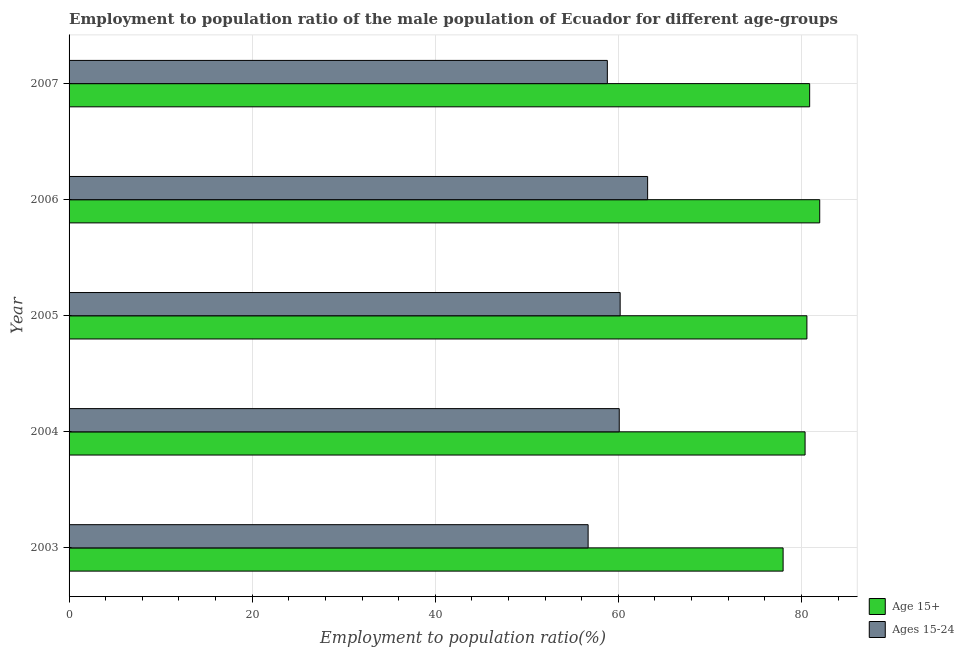How many different coloured bars are there?
Keep it short and to the point. 2. How many groups of bars are there?
Your answer should be compact. 5. Are the number of bars on each tick of the Y-axis equal?
Provide a succinct answer. Yes. How many bars are there on the 2nd tick from the top?
Make the answer very short. 2. How many bars are there on the 5th tick from the bottom?
Offer a very short reply. 2. What is the employment to population ratio(age 15+) in 2007?
Make the answer very short. 80.9. Across all years, what is the maximum employment to population ratio(age 15-24)?
Your response must be concise. 63.2. Across all years, what is the minimum employment to population ratio(age 15-24)?
Provide a succinct answer. 56.7. What is the total employment to population ratio(age 15-24) in the graph?
Keep it short and to the point. 299. What is the difference between the employment to population ratio(age 15+) in 2003 and that in 2006?
Offer a terse response. -4. What is the difference between the employment to population ratio(age 15+) in 2006 and the employment to population ratio(age 15-24) in 2005?
Give a very brief answer. 21.8. What is the average employment to population ratio(age 15-24) per year?
Your answer should be compact. 59.8. In the year 2003, what is the difference between the employment to population ratio(age 15+) and employment to population ratio(age 15-24)?
Your response must be concise. 21.3. Is the difference between the employment to population ratio(age 15+) in 2004 and 2005 greater than the difference between the employment to population ratio(age 15-24) in 2004 and 2005?
Offer a terse response. No. What is the difference between the highest and the second highest employment to population ratio(age 15-24)?
Ensure brevity in your answer.  3. In how many years, is the employment to population ratio(age 15+) greater than the average employment to population ratio(age 15+) taken over all years?
Keep it short and to the point. 4. What does the 1st bar from the top in 2004 represents?
Make the answer very short. Ages 15-24. What does the 2nd bar from the bottom in 2003 represents?
Offer a very short reply. Ages 15-24. How many bars are there?
Your answer should be very brief. 10. Are all the bars in the graph horizontal?
Your answer should be very brief. Yes. How many years are there in the graph?
Provide a short and direct response. 5. Does the graph contain any zero values?
Your response must be concise. No. Where does the legend appear in the graph?
Your answer should be very brief. Bottom right. How many legend labels are there?
Offer a terse response. 2. What is the title of the graph?
Your answer should be very brief. Employment to population ratio of the male population of Ecuador for different age-groups. Does "Netherlands" appear as one of the legend labels in the graph?
Your answer should be very brief. No. What is the label or title of the X-axis?
Keep it short and to the point. Employment to population ratio(%). What is the label or title of the Y-axis?
Provide a succinct answer. Year. What is the Employment to population ratio(%) of Age 15+ in 2003?
Offer a very short reply. 78. What is the Employment to population ratio(%) of Ages 15-24 in 2003?
Provide a short and direct response. 56.7. What is the Employment to population ratio(%) in Age 15+ in 2004?
Provide a succinct answer. 80.4. What is the Employment to population ratio(%) in Ages 15-24 in 2004?
Provide a short and direct response. 60.1. What is the Employment to population ratio(%) in Age 15+ in 2005?
Provide a short and direct response. 80.6. What is the Employment to population ratio(%) of Ages 15-24 in 2005?
Keep it short and to the point. 60.2. What is the Employment to population ratio(%) in Ages 15-24 in 2006?
Offer a very short reply. 63.2. What is the Employment to population ratio(%) of Age 15+ in 2007?
Your answer should be very brief. 80.9. What is the Employment to population ratio(%) in Ages 15-24 in 2007?
Your response must be concise. 58.8. Across all years, what is the maximum Employment to population ratio(%) in Ages 15-24?
Make the answer very short. 63.2. Across all years, what is the minimum Employment to population ratio(%) in Age 15+?
Your response must be concise. 78. Across all years, what is the minimum Employment to population ratio(%) in Ages 15-24?
Provide a succinct answer. 56.7. What is the total Employment to population ratio(%) of Age 15+ in the graph?
Ensure brevity in your answer.  401.9. What is the total Employment to population ratio(%) of Ages 15-24 in the graph?
Make the answer very short. 299. What is the difference between the Employment to population ratio(%) in Age 15+ in 2003 and that in 2004?
Your answer should be very brief. -2.4. What is the difference between the Employment to population ratio(%) in Age 15+ in 2003 and that in 2005?
Offer a very short reply. -2.6. What is the difference between the Employment to population ratio(%) of Ages 15-24 in 2003 and that in 2007?
Offer a very short reply. -2.1. What is the difference between the Employment to population ratio(%) of Ages 15-24 in 2004 and that in 2005?
Keep it short and to the point. -0.1. What is the difference between the Employment to population ratio(%) of Ages 15-24 in 2004 and that in 2006?
Ensure brevity in your answer.  -3.1. What is the difference between the Employment to population ratio(%) of Age 15+ in 2005 and that in 2006?
Your answer should be compact. -1.4. What is the difference between the Employment to population ratio(%) of Ages 15-24 in 2005 and that in 2006?
Your answer should be very brief. -3. What is the difference between the Employment to population ratio(%) of Ages 15-24 in 2006 and that in 2007?
Make the answer very short. 4.4. What is the difference between the Employment to population ratio(%) of Age 15+ in 2003 and the Employment to population ratio(%) of Ages 15-24 in 2005?
Make the answer very short. 17.8. What is the difference between the Employment to population ratio(%) in Age 15+ in 2003 and the Employment to population ratio(%) in Ages 15-24 in 2007?
Ensure brevity in your answer.  19.2. What is the difference between the Employment to population ratio(%) in Age 15+ in 2004 and the Employment to population ratio(%) in Ages 15-24 in 2005?
Offer a terse response. 20.2. What is the difference between the Employment to population ratio(%) in Age 15+ in 2004 and the Employment to population ratio(%) in Ages 15-24 in 2007?
Ensure brevity in your answer.  21.6. What is the difference between the Employment to population ratio(%) of Age 15+ in 2005 and the Employment to population ratio(%) of Ages 15-24 in 2007?
Ensure brevity in your answer.  21.8. What is the difference between the Employment to population ratio(%) in Age 15+ in 2006 and the Employment to population ratio(%) in Ages 15-24 in 2007?
Offer a terse response. 23.2. What is the average Employment to population ratio(%) in Age 15+ per year?
Provide a succinct answer. 80.38. What is the average Employment to population ratio(%) in Ages 15-24 per year?
Your answer should be compact. 59.8. In the year 2003, what is the difference between the Employment to population ratio(%) of Age 15+ and Employment to population ratio(%) of Ages 15-24?
Give a very brief answer. 21.3. In the year 2004, what is the difference between the Employment to population ratio(%) of Age 15+ and Employment to population ratio(%) of Ages 15-24?
Your answer should be very brief. 20.3. In the year 2005, what is the difference between the Employment to population ratio(%) in Age 15+ and Employment to population ratio(%) in Ages 15-24?
Give a very brief answer. 20.4. In the year 2006, what is the difference between the Employment to population ratio(%) of Age 15+ and Employment to population ratio(%) of Ages 15-24?
Keep it short and to the point. 18.8. In the year 2007, what is the difference between the Employment to population ratio(%) of Age 15+ and Employment to population ratio(%) of Ages 15-24?
Keep it short and to the point. 22.1. What is the ratio of the Employment to population ratio(%) in Age 15+ in 2003 to that in 2004?
Keep it short and to the point. 0.97. What is the ratio of the Employment to population ratio(%) in Ages 15-24 in 2003 to that in 2004?
Offer a very short reply. 0.94. What is the ratio of the Employment to population ratio(%) of Age 15+ in 2003 to that in 2005?
Offer a very short reply. 0.97. What is the ratio of the Employment to population ratio(%) of Ages 15-24 in 2003 to that in 2005?
Keep it short and to the point. 0.94. What is the ratio of the Employment to population ratio(%) in Age 15+ in 2003 to that in 2006?
Give a very brief answer. 0.95. What is the ratio of the Employment to population ratio(%) in Ages 15-24 in 2003 to that in 2006?
Your answer should be very brief. 0.9. What is the ratio of the Employment to population ratio(%) of Age 15+ in 2003 to that in 2007?
Your response must be concise. 0.96. What is the ratio of the Employment to population ratio(%) of Ages 15-24 in 2003 to that in 2007?
Provide a short and direct response. 0.96. What is the ratio of the Employment to population ratio(%) in Age 15+ in 2004 to that in 2005?
Provide a succinct answer. 1. What is the ratio of the Employment to population ratio(%) in Ages 15-24 in 2004 to that in 2005?
Your answer should be compact. 1. What is the ratio of the Employment to population ratio(%) of Age 15+ in 2004 to that in 2006?
Offer a terse response. 0.98. What is the ratio of the Employment to population ratio(%) of Ages 15-24 in 2004 to that in 2006?
Give a very brief answer. 0.95. What is the ratio of the Employment to population ratio(%) of Ages 15-24 in 2004 to that in 2007?
Ensure brevity in your answer.  1.02. What is the ratio of the Employment to population ratio(%) of Age 15+ in 2005 to that in 2006?
Your answer should be very brief. 0.98. What is the ratio of the Employment to population ratio(%) of Ages 15-24 in 2005 to that in 2006?
Your answer should be very brief. 0.95. What is the ratio of the Employment to population ratio(%) in Ages 15-24 in 2005 to that in 2007?
Provide a succinct answer. 1.02. What is the ratio of the Employment to population ratio(%) of Age 15+ in 2006 to that in 2007?
Ensure brevity in your answer.  1.01. What is the ratio of the Employment to population ratio(%) of Ages 15-24 in 2006 to that in 2007?
Make the answer very short. 1.07. What is the difference between the highest and the second highest Employment to population ratio(%) in Age 15+?
Your response must be concise. 1.1. 